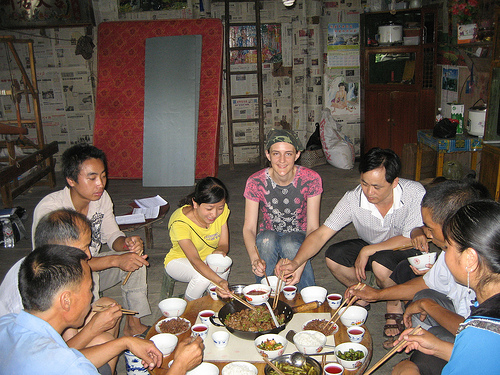<image>
Is there a food in the bowl? No. The food is not contained within the bowl. These objects have a different spatial relationship. 